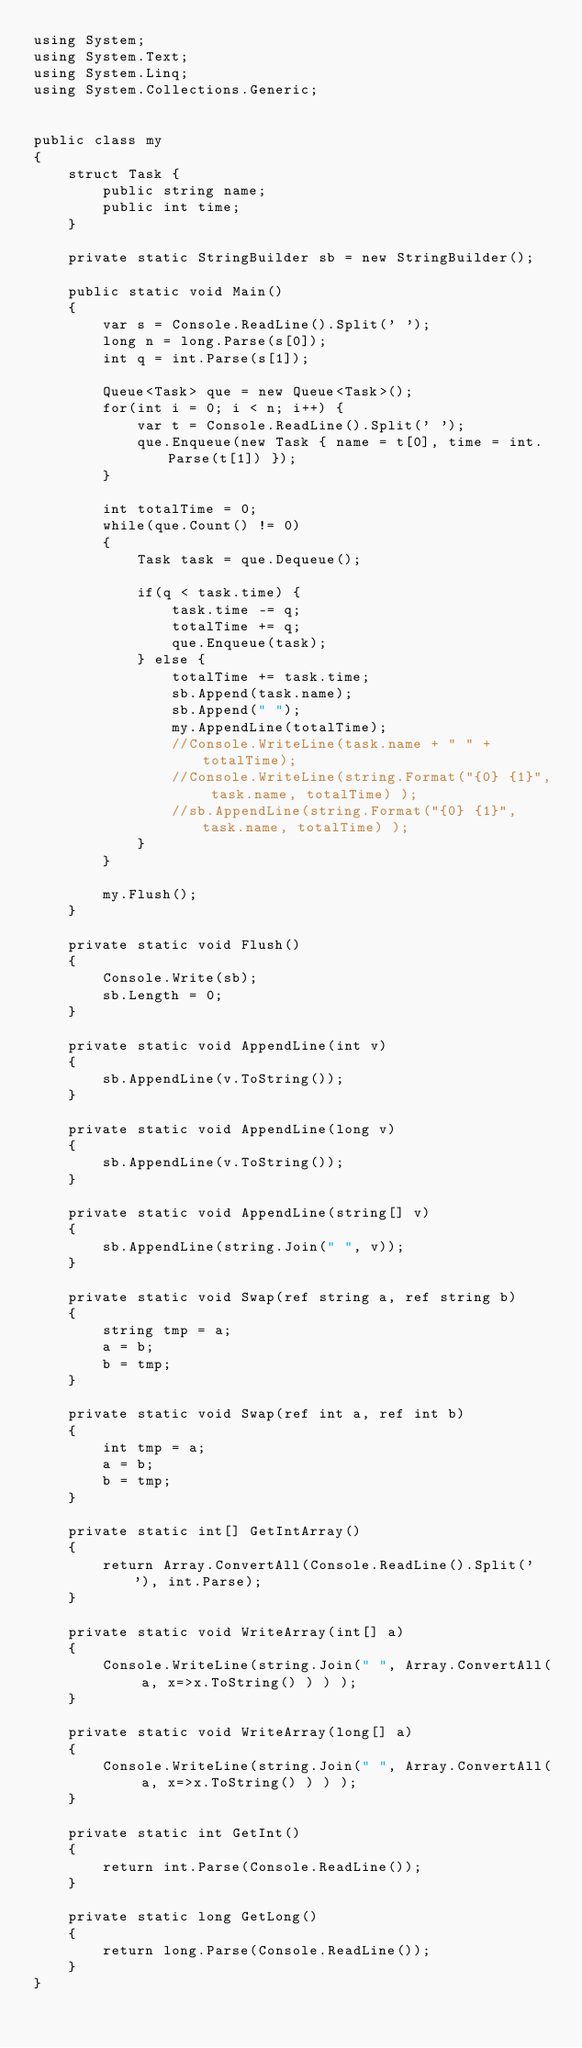<code> <loc_0><loc_0><loc_500><loc_500><_C#_>using System;
using System.Text;
using System.Linq;
using System.Collections.Generic;


public class my
{
	struct Task {
		public string name;
		public int time;
	}
	
	private static StringBuilder sb = new StringBuilder();
	
	public static void Main()
	{
		var s = Console.ReadLine().Split(' ');
		long n = long.Parse(s[0]);
		int q = int.Parse(s[1]);
		
		Queue<Task> que = new Queue<Task>();
		for(int i = 0; i < n; i++) {
			var t = Console.ReadLine().Split(' ');
			que.Enqueue(new Task { name = t[0], time = int.Parse(t[1]) });
		}
		
		int totalTime = 0;
		while(que.Count() != 0)
		{
			Task task = que.Dequeue();
			
			if(q < task.time) {
				task.time -= q;
				totalTime += q;
				que.Enqueue(task);
			} else {
				totalTime += task.time;
				sb.Append(task.name);
				sb.Append(" ");
				my.AppendLine(totalTime);
				//Console.WriteLine(task.name + " " + totalTime);
				//Console.WriteLine(string.Format("{0} {1}", task.name, totalTime) );
				//sb.AppendLine(string.Format("{0} {1}", task.name, totalTime) );
			}
		}
		
		my.Flush();
	}
	
	private static void Flush()
	{
		Console.Write(sb);
		sb.Length = 0;
	}
	
	private static void AppendLine(int v)
	{
		sb.AppendLine(v.ToString());
	}
	
	private static void AppendLine(long v)
	{
		sb.AppendLine(v.ToString());
	}
	
	private static void AppendLine(string[] v)
	{
		sb.AppendLine(string.Join(" ", v));
	}
	
	private static void Swap(ref string a, ref string b) 
	{
		string tmp = a;
		a = b;
		b = tmp;
	}
	
	private static void Swap(ref int a, ref int b) 
	{
		int tmp = a;
		a = b;
		b = tmp;
	}
	
	private static int[] GetIntArray()
	{
		return Array.ConvertAll(Console.ReadLine().Split(' '), int.Parse);
	}
	
	private static void WriteArray(int[] a)
	{
		Console.WriteLine(string.Join(" ", Array.ConvertAll( a, x=>x.ToString() ) ) );
	}
	
	private static void WriteArray(long[] a)
	{
		Console.WriteLine(string.Join(" ", Array.ConvertAll( a, x=>x.ToString() ) ) );
	}
	
	private static int GetInt()
	{
		return int.Parse(Console.ReadLine());
	}
	
	private static long GetLong()
	{
		return long.Parse(Console.ReadLine());
	}
}</code> 